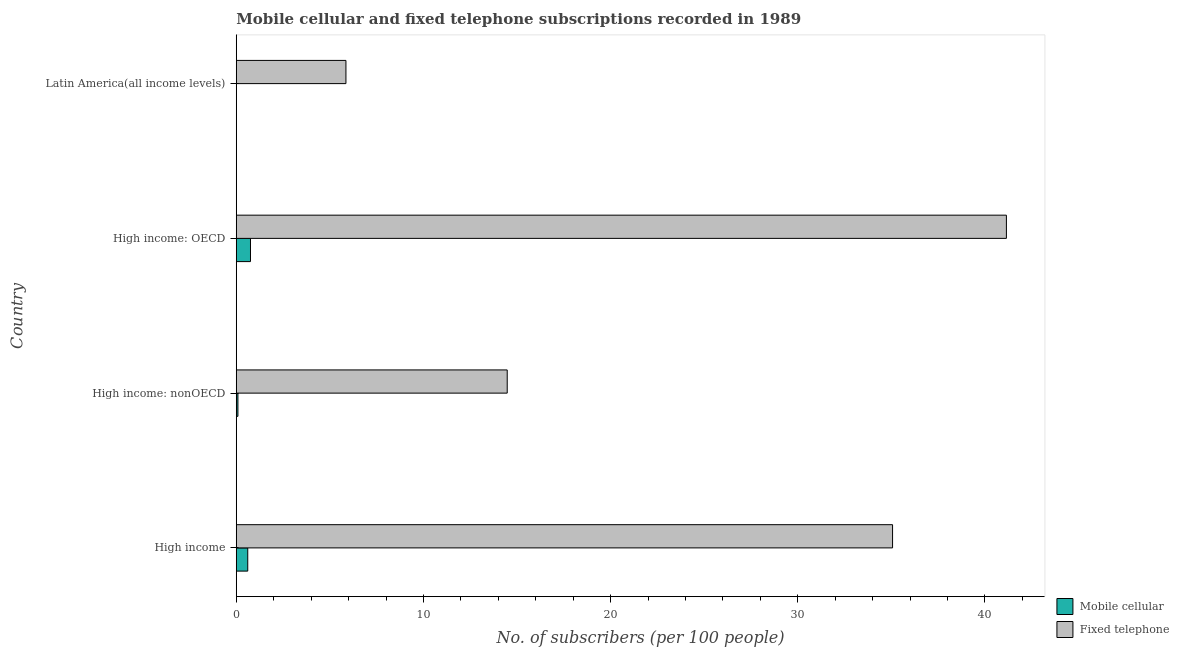Are the number of bars on each tick of the Y-axis equal?
Provide a short and direct response. Yes. How many bars are there on the 3rd tick from the top?
Keep it short and to the point. 2. How many bars are there on the 4th tick from the bottom?
Offer a very short reply. 2. What is the number of fixed telephone subscribers in Latin America(all income levels)?
Provide a succinct answer. 5.86. Across all countries, what is the maximum number of mobile cellular subscribers?
Give a very brief answer. 0.76. Across all countries, what is the minimum number of mobile cellular subscribers?
Keep it short and to the point. 0.01. In which country was the number of mobile cellular subscribers maximum?
Provide a short and direct response. High income: OECD. In which country was the number of fixed telephone subscribers minimum?
Ensure brevity in your answer.  Latin America(all income levels). What is the total number of fixed telephone subscribers in the graph?
Provide a short and direct response. 96.54. What is the difference between the number of fixed telephone subscribers in High income and that in High income: OECD?
Keep it short and to the point. -6.08. What is the difference between the number of fixed telephone subscribers in High income: nonOECD and the number of mobile cellular subscribers in Latin America(all income levels)?
Keep it short and to the point. 14.47. What is the average number of fixed telephone subscribers per country?
Offer a terse response. 24.14. What is the difference between the number of fixed telephone subscribers and number of mobile cellular subscribers in High income: nonOECD?
Offer a very short reply. 14.39. What is the ratio of the number of fixed telephone subscribers in High income: OECD to that in Latin America(all income levels)?
Offer a terse response. 7.02. What is the difference between the highest and the second highest number of mobile cellular subscribers?
Your answer should be very brief. 0.15. What is the difference between the highest and the lowest number of fixed telephone subscribers?
Offer a very short reply. 35.29. In how many countries, is the number of mobile cellular subscribers greater than the average number of mobile cellular subscribers taken over all countries?
Provide a succinct answer. 2. What does the 1st bar from the top in High income: OECD represents?
Ensure brevity in your answer.  Fixed telephone. What does the 1st bar from the bottom in High income represents?
Make the answer very short. Mobile cellular. How many bars are there?
Your response must be concise. 8. How many countries are there in the graph?
Ensure brevity in your answer.  4. Where does the legend appear in the graph?
Make the answer very short. Bottom right. How many legend labels are there?
Keep it short and to the point. 2. What is the title of the graph?
Your response must be concise. Mobile cellular and fixed telephone subscriptions recorded in 1989. What is the label or title of the X-axis?
Your response must be concise. No. of subscribers (per 100 people). What is the label or title of the Y-axis?
Keep it short and to the point. Country. What is the No. of subscribers (per 100 people) of Mobile cellular in High income?
Give a very brief answer. 0.61. What is the No. of subscribers (per 100 people) of Fixed telephone in High income?
Provide a short and direct response. 35.06. What is the No. of subscribers (per 100 people) of Mobile cellular in High income: nonOECD?
Keep it short and to the point. 0.09. What is the No. of subscribers (per 100 people) of Fixed telephone in High income: nonOECD?
Your answer should be compact. 14.48. What is the No. of subscribers (per 100 people) of Mobile cellular in High income: OECD?
Provide a succinct answer. 0.76. What is the No. of subscribers (per 100 people) in Fixed telephone in High income: OECD?
Your answer should be compact. 41.15. What is the No. of subscribers (per 100 people) in Mobile cellular in Latin America(all income levels)?
Provide a short and direct response. 0.01. What is the No. of subscribers (per 100 people) of Fixed telephone in Latin America(all income levels)?
Offer a terse response. 5.86. Across all countries, what is the maximum No. of subscribers (per 100 people) of Mobile cellular?
Give a very brief answer. 0.76. Across all countries, what is the maximum No. of subscribers (per 100 people) in Fixed telephone?
Offer a terse response. 41.15. Across all countries, what is the minimum No. of subscribers (per 100 people) of Mobile cellular?
Offer a very short reply. 0.01. Across all countries, what is the minimum No. of subscribers (per 100 people) of Fixed telephone?
Provide a succinct answer. 5.86. What is the total No. of subscribers (per 100 people) of Mobile cellular in the graph?
Your answer should be very brief. 1.47. What is the total No. of subscribers (per 100 people) of Fixed telephone in the graph?
Your response must be concise. 96.54. What is the difference between the No. of subscribers (per 100 people) of Mobile cellular in High income and that in High income: nonOECD?
Your response must be concise. 0.53. What is the difference between the No. of subscribers (per 100 people) of Fixed telephone in High income and that in High income: nonOECD?
Keep it short and to the point. 20.59. What is the difference between the No. of subscribers (per 100 people) in Mobile cellular in High income and that in High income: OECD?
Give a very brief answer. -0.15. What is the difference between the No. of subscribers (per 100 people) of Fixed telephone in High income and that in High income: OECD?
Keep it short and to the point. -6.08. What is the difference between the No. of subscribers (per 100 people) of Mobile cellular in High income and that in Latin America(all income levels)?
Make the answer very short. 0.61. What is the difference between the No. of subscribers (per 100 people) of Fixed telephone in High income and that in Latin America(all income levels)?
Your answer should be compact. 29.2. What is the difference between the No. of subscribers (per 100 people) in Mobile cellular in High income: nonOECD and that in High income: OECD?
Provide a succinct answer. -0.67. What is the difference between the No. of subscribers (per 100 people) in Fixed telephone in High income: nonOECD and that in High income: OECD?
Make the answer very short. -26.67. What is the difference between the No. of subscribers (per 100 people) in Mobile cellular in High income: nonOECD and that in Latin America(all income levels)?
Provide a short and direct response. 0.08. What is the difference between the No. of subscribers (per 100 people) in Fixed telephone in High income: nonOECD and that in Latin America(all income levels)?
Provide a short and direct response. 8.62. What is the difference between the No. of subscribers (per 100 people) in Mobile cellular in High income: OECD and that in Latin America(all income levels)?
Keep it short and to the point. 0.75. What is the difference between the No. of subscribers (per 100 people) in Fixed telephone in High income: OECD and that in Latin America(all income levels)?
Keep it short and to the point. 35.29. What is the difference between the No. of subscribers (per 100 people) of Mobile cellular in High income and the No. of subscribers (per 100 people) of Fixed telephone in High income: nonOECD?
Your answer should be very brief. -13.86. What is the difference between the No. of subscribers (per 100 people) in Mobile cellular in High income and the No. of subscribers (per 100 people) in Fixed telephone in High income: OECD?
Offer a terse response. -40.53. What is the difference between the No. of subscribers (per 100 people) of Mobile cellular in High income and the No. of subscribers (per 100 people) of Fixed telephone in Latin America(all income levels)?
Provide a succinct answer. -5.25. What is the difference between the No. of subscribers (per 100 people) in Mobile cellular in High income: nonOECD and the No. of subscribers (per 100 people) in Fixed telephone in High income: OECD?
Offer a terse response. -41.06. What is the difference between the No. of subscribers (per 100 people) of Mobile cellular in High income: nonOECD and the No. of subscribers (per 100 people) of Fixed telephone in Latin America(all income levels)?
Ensure brevity in your answer.  -5.77. What is the difference between the No. of subscribers (per 100 people) of Mobile cellular in High income: OECD and the No. of subscribers (per 100 people) of Fixed telephone in Latin America(all income levels)?
Offer a terse response. -5.1. What is the average No. of subscribers (per 100 people) of Mobile cellular per country?
Provide a short and direct response. 0.37. What is the average No. of subscribers (per 100 people) of Fixed telephone per country?
Offer a terse response. 24.14. What is the difference between the No. of subscribers (per 100 people) in Mobile cellular and No. of subscribers (per 100 people) in Fixed telephone in High income?
Provide a succinct answer. -34.45. What is the difference between the No. of subscribers (per 100 people) of Mobile cellular and No. of subscribers (per 100 people) of Fixed telephone in High income: nonOECD?
Offer a very short reply. -14.39. What is the difference between the No. of subscribers (per 100 people) in Mobile cellular and No. of subscribers (per 100 people) in Fixed telephone in High income: OECD?
Give a very brief answer. -40.38. What is the difference between the No. of subscribers (per 100 people) of Mobile cellular and No. of subscribers (per 100 people) of Fixed telephone in Latin America(all income levels)?
Your response must be concise. -5.85. What is the ratio of the No. of subscribers (per 100 people) of Mobile cellular in High income to that in High income: nonOECD?
Your answer should be very brief. 6.9. What is the ratio of the No. of subscribers (per 100 people) of Fixed telephone in High income to that in High income: nonOECD?
Make the answer very short. 2.42. What is the ratio of the No. of subscribers (per 100 people) of Mobile cellular in High income to that in High income: OECD?
Provide a succinct answer. 0.81. What is the ratio of the No. of subscribers (per 100 people) of Fixed telephone in High income to that in High income: OECD?
Ensure brevity in your answer.  0.85. What is the ratio of the No. of subscribers (per 100 people) in Mobile cellular in High income to that in Latin America(all income levels)?
Make the answer very short. 85. What is the ratio of the No. of subscribers (per 100 people) in Fixed telephone in High income to that in Latin America(all income levels)?
Offer a terse response. 5.98. What is the ratio of the No. of subscribers (per 100 people) of Mobile cellular in High income: nonOECD to that in High income: OECD?
Ensure brevity in your answer.  0.12. What is the ratio of the No. of subscribers (per 100 people) in Fixed telephone in High income: nonOECD to that in High income: OECD?
Ensure brevity in your answer.  0.35. What is the ratio of the No. of subscribers (per 100 people) of Mobile cellular in High income: nonOECD to that in Latin America(all income levels)?
Offer a terse response. 12.32. What is the ratio of the No. of subscribers (per 100 people) of Fixed telephone in High income: nonOECD to that in Latin America(all income levels)?
Offer a terse response. 2.47. What is the ratio of the No. of subscribers (per 100 people) of Mobile cellular in High income: OECD to that in Latin America(all income levels)?
Give a very brief answer. 105.22. What is the ratio of the No. of subscribers (per 100 people) in Fixed telephone in High income: OECD to that in Latin America(all income levels)?
Ensure brevity in your answer.  7.02. What is the difference between the highest and the second highest No. of subscribers (per 100 people) in Mobile cellular?
Provide a short and direct response. 0.15. What is the difference between the highest and the second highest No. of subscribers (per 100 people) of Fixed telephone?
Ensure brevity in your answer.  6.08. What is the difference between the highest and the lowest No. of subscribers (per 100 people) of Mobile cellular?
Make the answer very short. 0.75. What is the difference between the highest and the lowest No. of subscribers (per 100 people) in Fixed telephone?
Provide a succinct answer. 35.29. 